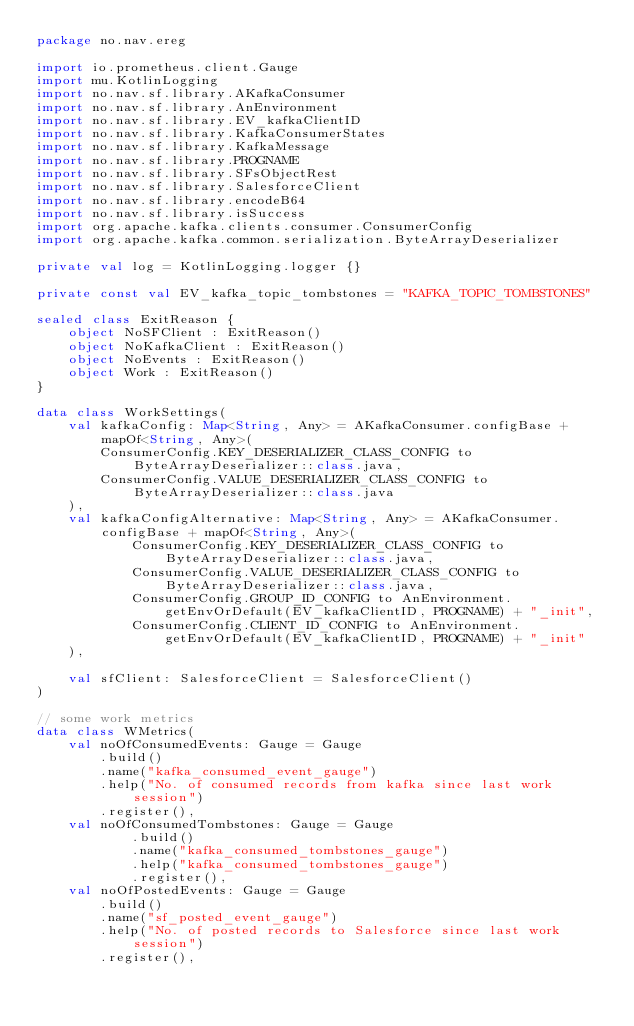Convert code to text. <code><loc_0><loc_0><loc_500><loc_500><_Kotlin_>package no.nav.ereg

import io.prometheus.client.Gauge
import mu.KotlinLogging
import no.nav.sf.library.AKafkaConsumer
import no.nav.sf.library.AnEnvironment
import no.nav.sf.library.EV_kafkaClientID
import no.nav.sf.library.KafkaConsumerStates
import no.nav.sf.library.KafkaMessage
import no.nav.sf.library.PROGNAME
import no.nav.sf.library.SFsObjectRest
import no.nav.sf.library.SalesforceClient
import no.nav.sf.library.encodeB64
import no.nav.sf.library.isSuccess
import org.apache.kafka.clients.consumer.ConsumerConfig
import org.apache.kafka.common.serialization.ByteArrayDeserializer

private val log = KotlinLogging.logger {}

private const val EV_kafka_topic_tombstones = "KAFKA_TOPIC_TOMBSTONES"

sealed class ExitReason {
    object NoSFClient : ExitReason()
    object NoKafkaClient : ExitReason()
    object NoEvents : ExitReason()
    object Work : ExitReason()
}

data class WorkSettings(
    val kafkaConfig: Map<String, Any> = AKafkaConsumer.configBase + mapOf<String, Any>(
        ConsumerConfig.KEY_DESERIALIZER_CLASS_CONFIG to ByteArrayDeserializer::class.java,
        ConsumerConfig.VALUE_DESERIALIZER_CLASS_CONFIG to ByteArrayDeserializer::class.java
    ),
    val kafkaConfigAlternative: Map<String, Any> = AKafkaConsumer.configBase + mapOf<String, Any>(
            ConsumerConfig.KEY_DESERIALIZER_CLASS_CONFIG to ByteArrayDeserializer::class.java,
            ConsumerConfig.VALUE_DESERIALIZER_CLASS_CONFIG to ByteArrayDeserializer::class.java,
            ConsumerConfig.GROUP_ID_CONFIG to AnEnvironment.getEnvOrDefault(EV_kafkaClientID, PROGNAME) + "_init",
            ConsumerConfig.CLIENT_ID_CONFIG to AnEnvironment.getEnvOrDefault(EV_kafkaClientID, PROGNAME) + "_init"
    ),

    val sfClient: SalesforceClient = SalesforceClient()
)

// some work metrics
data class WMetrics(
    val noOfConsumedEvents: Gauge = Gauge
        .build()
        .name("kafka_consumed_event_gauge")
        .help("No. of consumed records from kafka since last work session")
        .register(),
    val noOfConsumedTombstones: Gauge = Gauge
            .build()
            .name("kafka_consumed_tombstones_gauge")
            .help("kafka_consumed_tombstones_gauge")
            .register(),
    val noOfPostedEvents: Gauge = Gauge
        .build()
        .name("sf_posted_event_gauge")
        .help("No. of posted records to Salesforce since last work session")
        .register(),</code> 